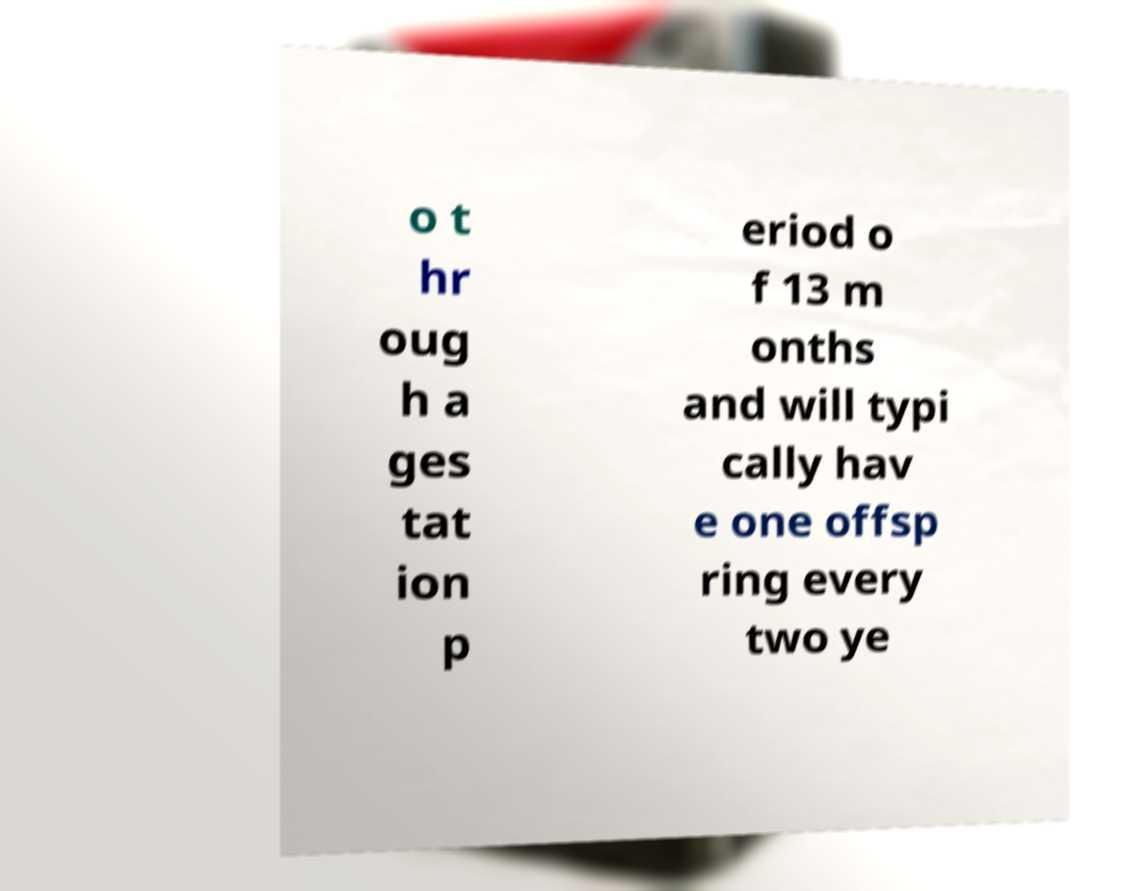For documentation purposes, I need the text within this image transcribed. Could you provide that? o t hr oug h a ges tat ion p eriod o f 13 m onths and will typi cally hav e one offsp ring every two ye 